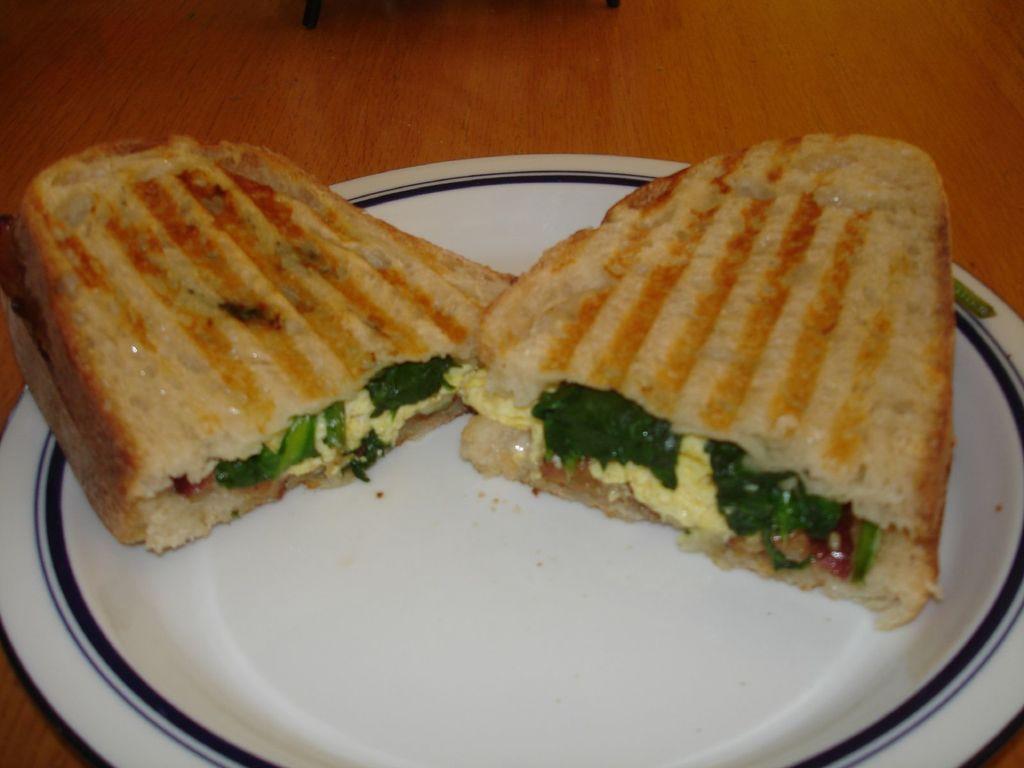How would you summarize this image in a sentence or two? In the middle of the image there is a plate with two slices of sandwich on the wooden table. 